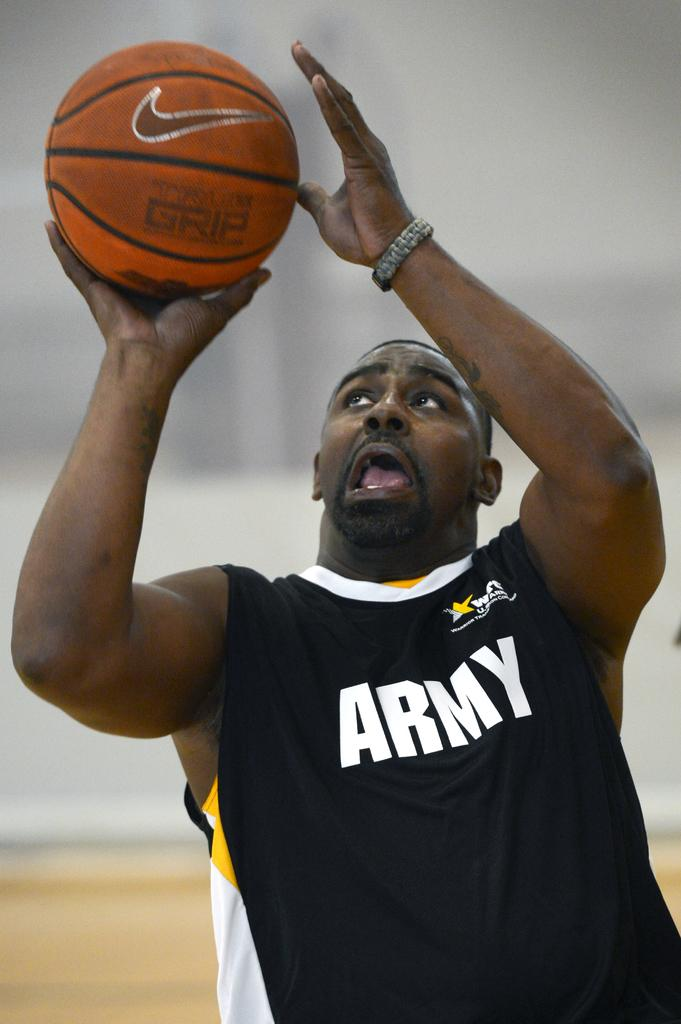<image>
Create a compact narrative representing the image presented. A basketball player wearing a black shirt that says ARMY on it. 